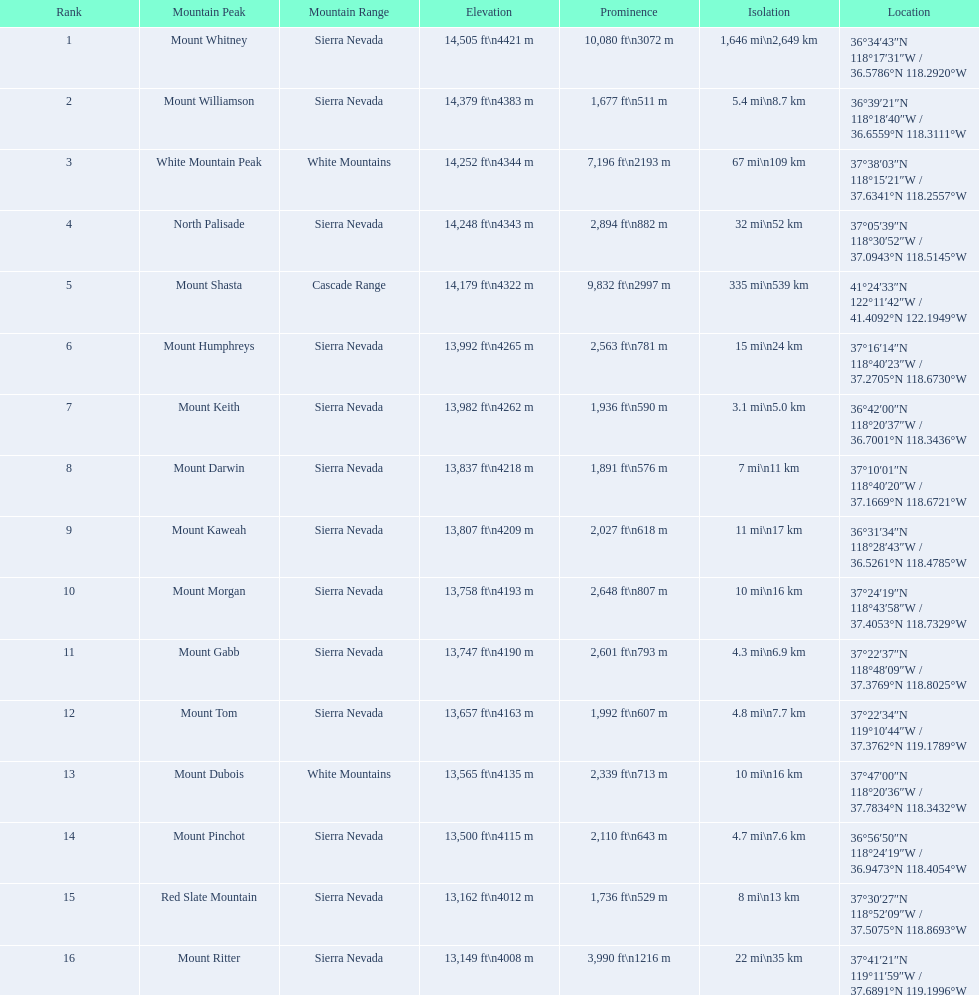What is the total elevation (in ft) of mount whitney? 14,505 ft. 